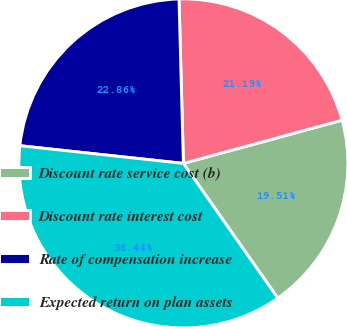Convert chart. <chart><loc_0><loc_0><loc_500><loc_500><pie_chart><fcel>Discount rate service cost (b)<fcel>Discount rate interest cost<fcel>Rate of compensation increase<fcel>Expected return on plan assets<nl><fcel>19.51%<fcel>21.19%<fcel>22.86%<fcel>36.44%<nl></chart> 